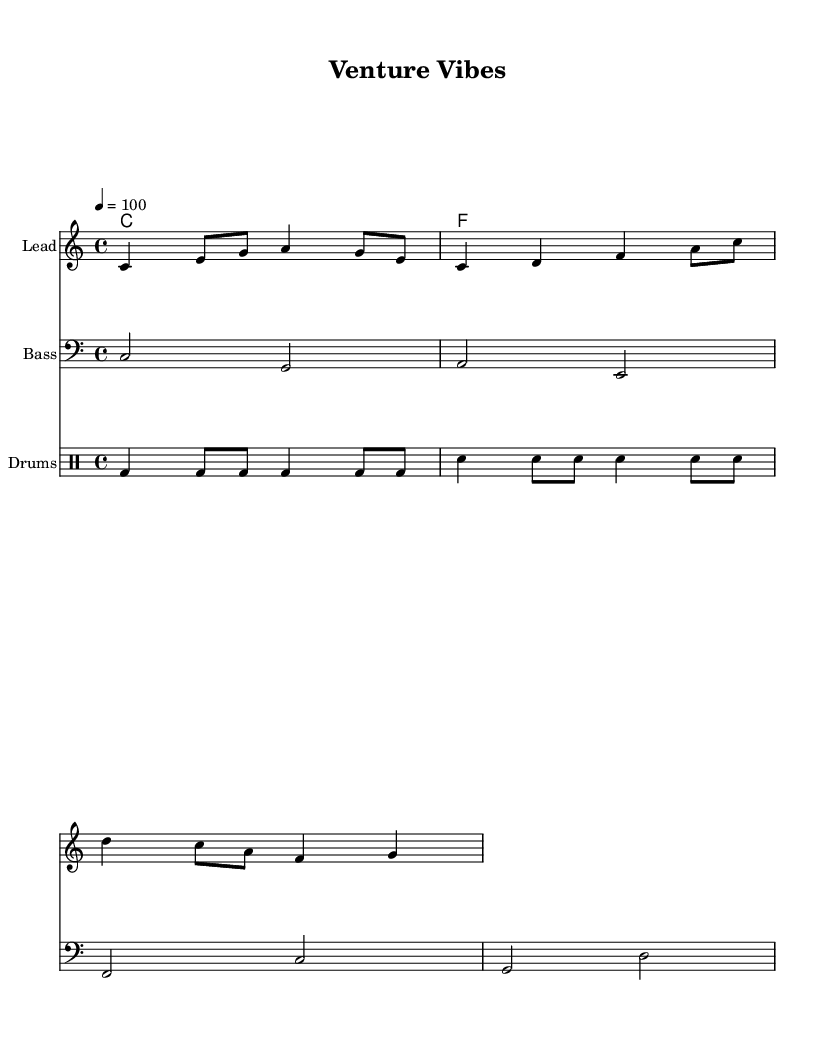What is the key signature of this music? The key signature is C major, which is indicated by the absence of any sharps or flats in the key signature section.
Answer: C major What is the time signature? The time signature is shown as 4/4, which indicates that there are four beats in each measure and the quarter note receives one beat.
Answer: 4/4 What is the tempo marking? The tempo is marked as 4 = 100, which indicates that the quarter note should be played at a speed of 100 beats per minute.
Answer: 100 How many measures are in the melody section? By counting the measures in the melody part indicated in the score, there are four distinct measures included in the melody section.
Answer: 4 What instrumentation is used in this piece? The score includes parts for lead, bass, and drums, indicating that the instrumentation consists of these three components.
Answer: Lead, Bass, Drums What is the overall theme of the lyrics? The lyrics celebrate entrepreneurship and business success, reflected in the phrases that reference reaching high and dreams touching the sky.
Answer: Celebration of entrepreneurship 